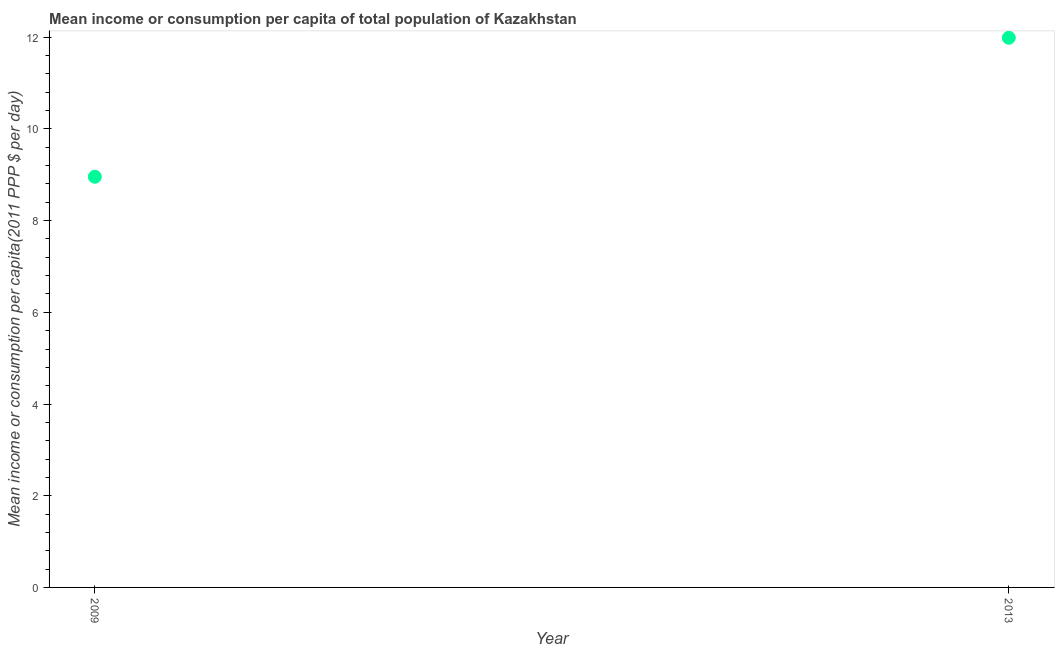What is the mean income or consumption in 2009?
Offer a terse response. 8.96. Across all years, what is the maximum mean income or consumption?
Provide a succinct answer. 11.99. Across all years, what is the minimum mean income or consumption?
Provide a short and direct response. 8.96. In which year was the mean income or consumption maximum?
Your answer should be very brief. 2013. In which year was the mean income or consumption minimum?
Give a very brief answer. 2009. What is the sum of the mean income or consumption?
Ensure brevity in your answer.  20.94. What is the difference between the mean income or consumption in 2009 and 2013?
Provide a succinct answer. -3.03. What is the average mean income or consumption per year?
Offer a terse response. 10.47. What is the median mean income or consumption?
Offer a very short reply. 10.47. In how many years, is the mean income or consumption greater than 5.6 $?
Ensure brevity in your answer.  2. What is the ratio of the mean income or consumption in 2009 to that in 2013?
Offer a very short reply. 0.75. Is the mean income or consumption in 2009 less than that in 2013?
Provide a short and direct response. Yes. In how many years, is the mean income or consumption greater than the average mean income or consumption taken over all years?
Provide a short and direct response. 1. Does the mean income or consumption monotonically increase over the years?
Your response must be concise. Yes. How many dotlines are there?
Give a very brief answer. 1. How many years are there in the graph?
Give a very brief answer. 2. What is the difference between two consecutive major ticks on the Y-axis?
Offer a very short reply. 2. Does the graph contain grids?
Your answer should be very brief. No. What is the title of the graph?
Your response must be concise. Mean income or consumption per capita of total population of Kazakhstan. What is the label or title of the X-axis?
Offer a terse response. Year. What is the label or title of the Y-axis?
Offer a terse response. Mean income or consumption per capita(2011 PPP $ per day). What is the Mean income or consumption per capita(2011 PPP $ per day) in 2009?
Your answer should be compact. 8.96. What is the Mean income or consumption per capita(2011 PPP $ per day) in 2013?
Provide a short and direct response. 11.99. What is the difference between the Mean income or consumption per capita(2011 PPP $ per day) in 2009 and 2013?
Your response must be concise. -3.03. What is the ratio of the Mean income or consumption per capita(2011 PPP $ per day) in 2009 to that in 2013?
Your answer should be very brief. 0.75. 